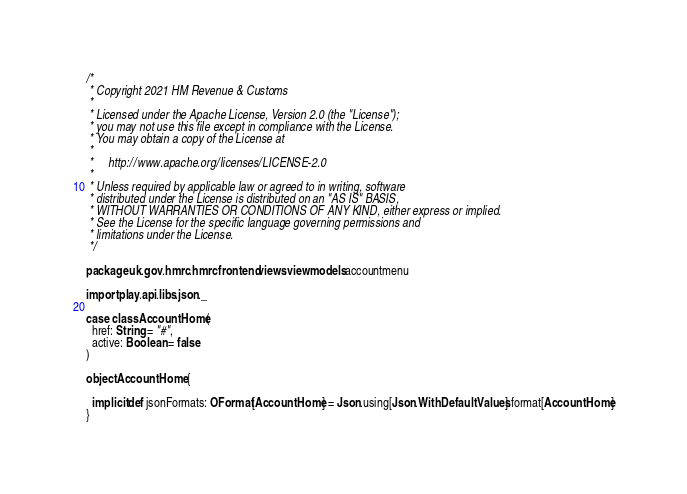Convert code to text. <code><loc_0><loc_0><loc_500><loc_500><_Scala_>/*
 * Copyright 2021 HM Revenue & Customs
 *
 * Licensed under the Apache License, Version 2.0 (the "License");
 * you may not use this file except in compliance with the License.
 * You may obtain a copy of the License at
 *
 *     http://www.apache.org/licenses/LICENSE-2.0
 *
 * Unless required by applicable law or agreed to in writing, software
 * distributed under the License is distributed on an "AS IS" BASIS,
 * WITHOUT WARRANTIES OR CONDITIONS OF ANY KIND, either express or implied.
 * See the License for the specific language governing permissions and
 * limitations under the License.
 */

package uk.gov.hmrc.hmrcfrontend.views.viewmodels.accountmenu

import play.api.libs.json._

case class AccountHome(
  href: String = "#",
  active: Boolean = false
)

object AccountHome {

  implicit def jsonFormats: OFormat[AccountHome] = Json.using[Json.WithDefaultValues].format[AccountHome]
}
</code> 